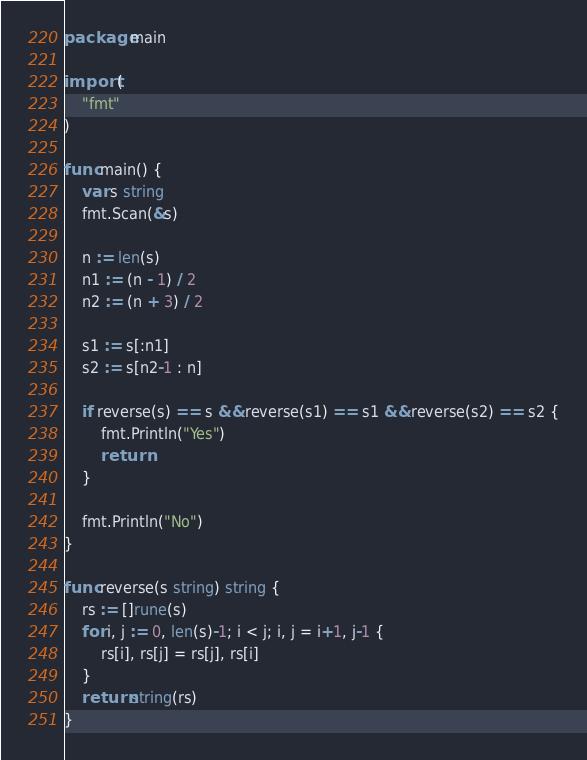Convert code to text. <code><loc_0><loc_0><loc_500><loc_500><_Go_>package main

import (
	"fmt"
)

func main() {
	var s string
	fmt.Scan(&s)

	n := len(s)
	n1 := (n - 1) / 2
	n2 := (n + 3) / 2

	s1 := s[:n1]
	s2 := s[n2-1 : n]

	if reverse(s) == s && reverse(s1) == s1 && reverse(s2) == s2 {
		fmt.Println("Yes")
		return
	}

	fmt.Println("No")
}

func reverse(s string) string {
	rs := []rune(s)
	for i, j := 0, len(s)-1; i < j; i, j = i+1, j-1 {
		rs[i], rs[j] = rs[j], rs[i]
	}
	return string(rs)
}
</code> 